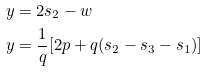<formula> <loc_0><loc_0><loc_500><loc_500>y & = 2 s _ { 2 } - w \\ y & = \frac { 1 } { q } [ 2 p + q ( s _ { 2 } - s _ { 3 } - s _ { 1 } ) ] \\</formula> 